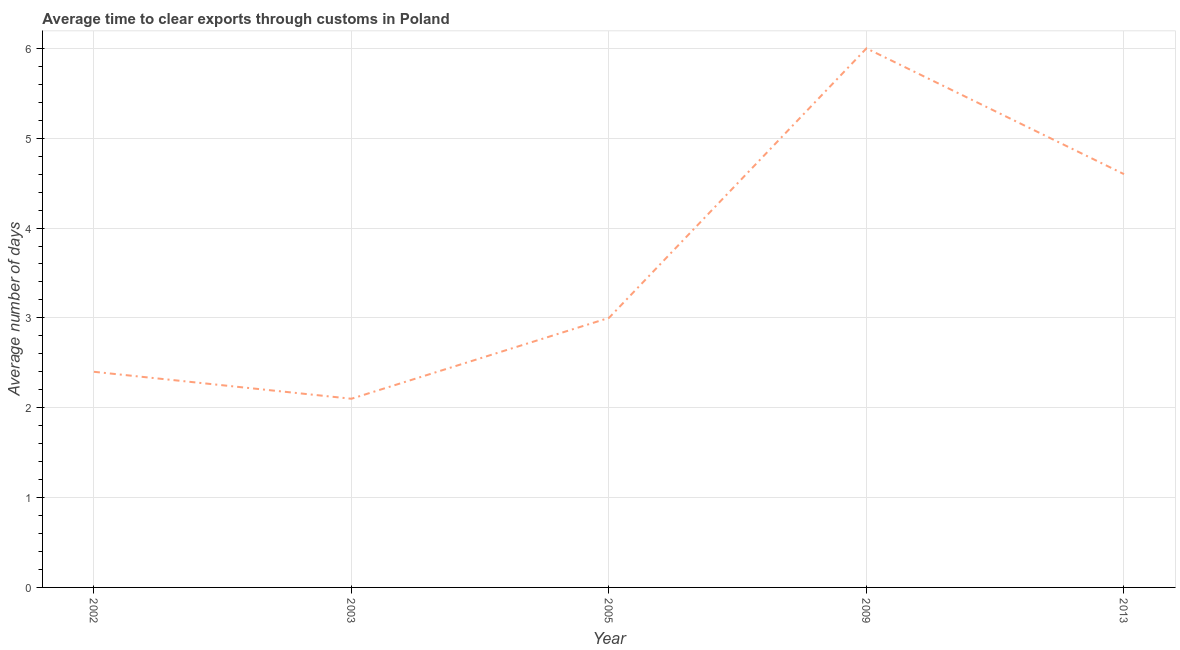In which year was the time to clear exports through customs maximum?
Your response must be concise. 2009. In which year was the time to clear exports through customs minimum?
Provide a short and direct response. 2003. What is the sum of the time to clear exports through customs?
Give a very brief answer. 18.1. What is the difference between the time to clear exports through customs in 2002 and 2009?
Provide a succinct answer. -3.6. What is the average time to clear exports through customs per year?
Provide a short and direct response. 3.62. What is the median time to clear exports through customs?
Your answer should be compact. 3. Do a majority of the years between 2013 and 2005 (inclusive) have time to clear exports through customs greater than 0.6000000000000001 days?
Your answer should be compact. No. What is the ratio of the time to clear exports through customs in 2002 to that in 2005?
Give a very brief answer. 0.8. Is the time to clear exports through customs in 2009 less than that in 2013?
Your answer should be very brief. No. What is the difference between the highest and the second highest time to clear exports through customs?
Keep it short and to the point. 1.4. In how many years, is the time to clear exports through customs greater than the average time to clear exports through customs taken over all years?
Your answer should be very brief. 2. How many lines are there?
Your answer should be very brief. 1. How many years are there in the graph?
Keep it short and to the point. 5. What is the difference between two consecutive major ticks on the Y-axis?
Your answer should be very brief. 1. Does the graph contain any zero values?
Give a very brief answer. No. Does the graph contain grids?
Your response must be concise. Yes. What is the title of the graph?
Give a very brief answer. Average time to clear exports through customs in Poland. What is the label or title of the X-axis?
Your answer should be compact. Year. What is the label or title of the Y-axis?
Make the answer very short. Average number of days. What is the Average number of days of 2002?
Your answer should be very brief. 2.4. What is the Average number of days of 2013?
Provide a succinct answer. 4.6. What is the difference between the Average number of days in 2002 and 2003?
Provide a succinct answer. 0.3. What is the difference between the Average number of days in 2002 and 2005?
Your answer should be very brief. -0.6. What is the difference between the Average number of days in 2002 and 2013?
Offer a terse response. -2.2. What is the difference between the Average number of days in 2003 and 2005?
Your answer should be compact. -0.9. What is the difference between the Average number of days in 2003 and 2009?
Ensure brevity in your answer.  -3.9. What is the difference between the Average number of days in 2003 and 2013?
Your response must be concise. -2.5. What is the difference between the Average number of days in 2005 and 2009?
Offer a terse response. -3. What is the difference between the Average number of days in 2009 and 2013?
Keep it short and to the point. 1.4. What is the ratio of the Average number of days in 2002 to that in 2003?
Provide a succinct answer. 1.14. What is the ratio of the Average number of days in 2002 to that in 2005?
Make the answer very short. 0.8. What is the ratio of the Average number of days in 2002 to that in 2009?
Your answer should be compact. 0.4. What is the ratio of the Average number of days in 2002 to that in 2013?
Ensure brevity in your answer.  0.52. What is the ratio of the Average number of days in 2003 to that in 2005?
Offer a very short reply. 0.7. What is the ratio of the Average number of days in 2003 to that in 2009?
Your response must be concise. 0.35. What is the ratio of the Average number of days in 2003 to that in 2013?
Make the answer very short. 0.46. What is the ratio of the Average number of days in 2005 to that in 2013?
Your answer should be compact. 0.65. What is the ratio of the Average number of days in 2009 to that in 2013?
Your answer should be very brief. 1.3. 